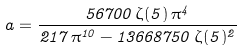Convert formula to latex. <formula><loc_0><loc_0><loc_500><loc_500>a = \frac { 5 6 7 0 0 \, \zeta ( 5 ) \, \pi ^ { 4 } } { 2 1 7 \, \pi ^ { 1 0 } - 1 3 6 6 8 7 5 0 \, \zeta ( 5 ) ^ { 2 } }</formula> 